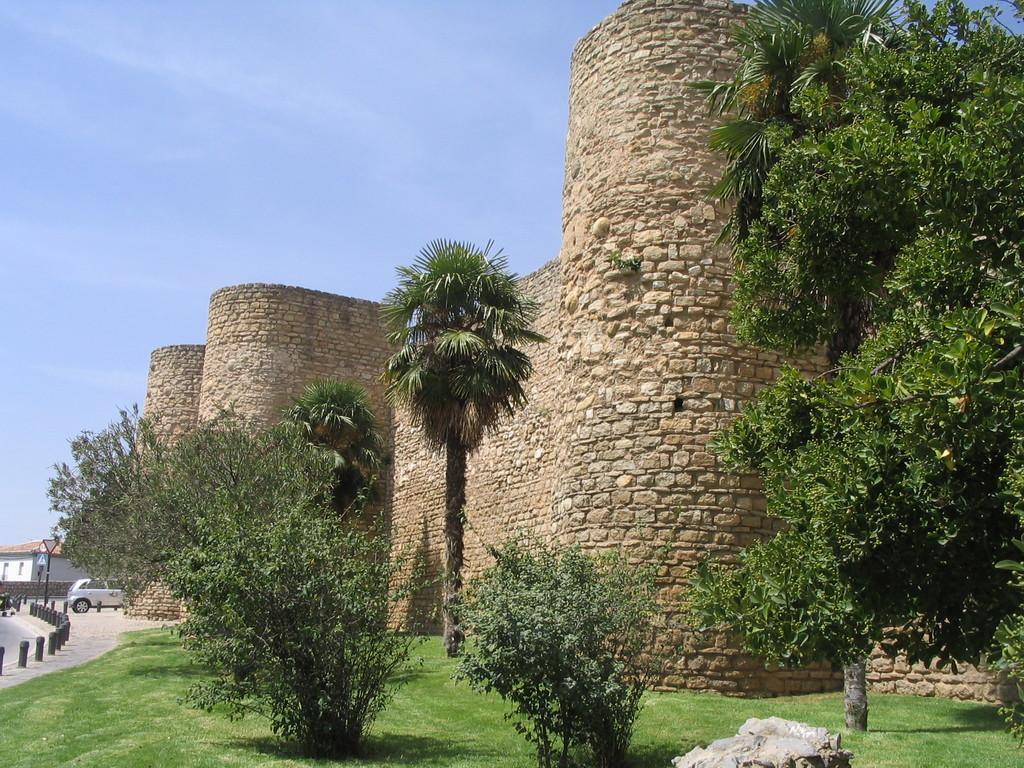Could you give a brief overview of what you see in this image? There is a huge fort and around the fort there is a lot of grass and many trees,in the front side there is a car parked and behind the car there is some compartment,in the background there is a sky. 